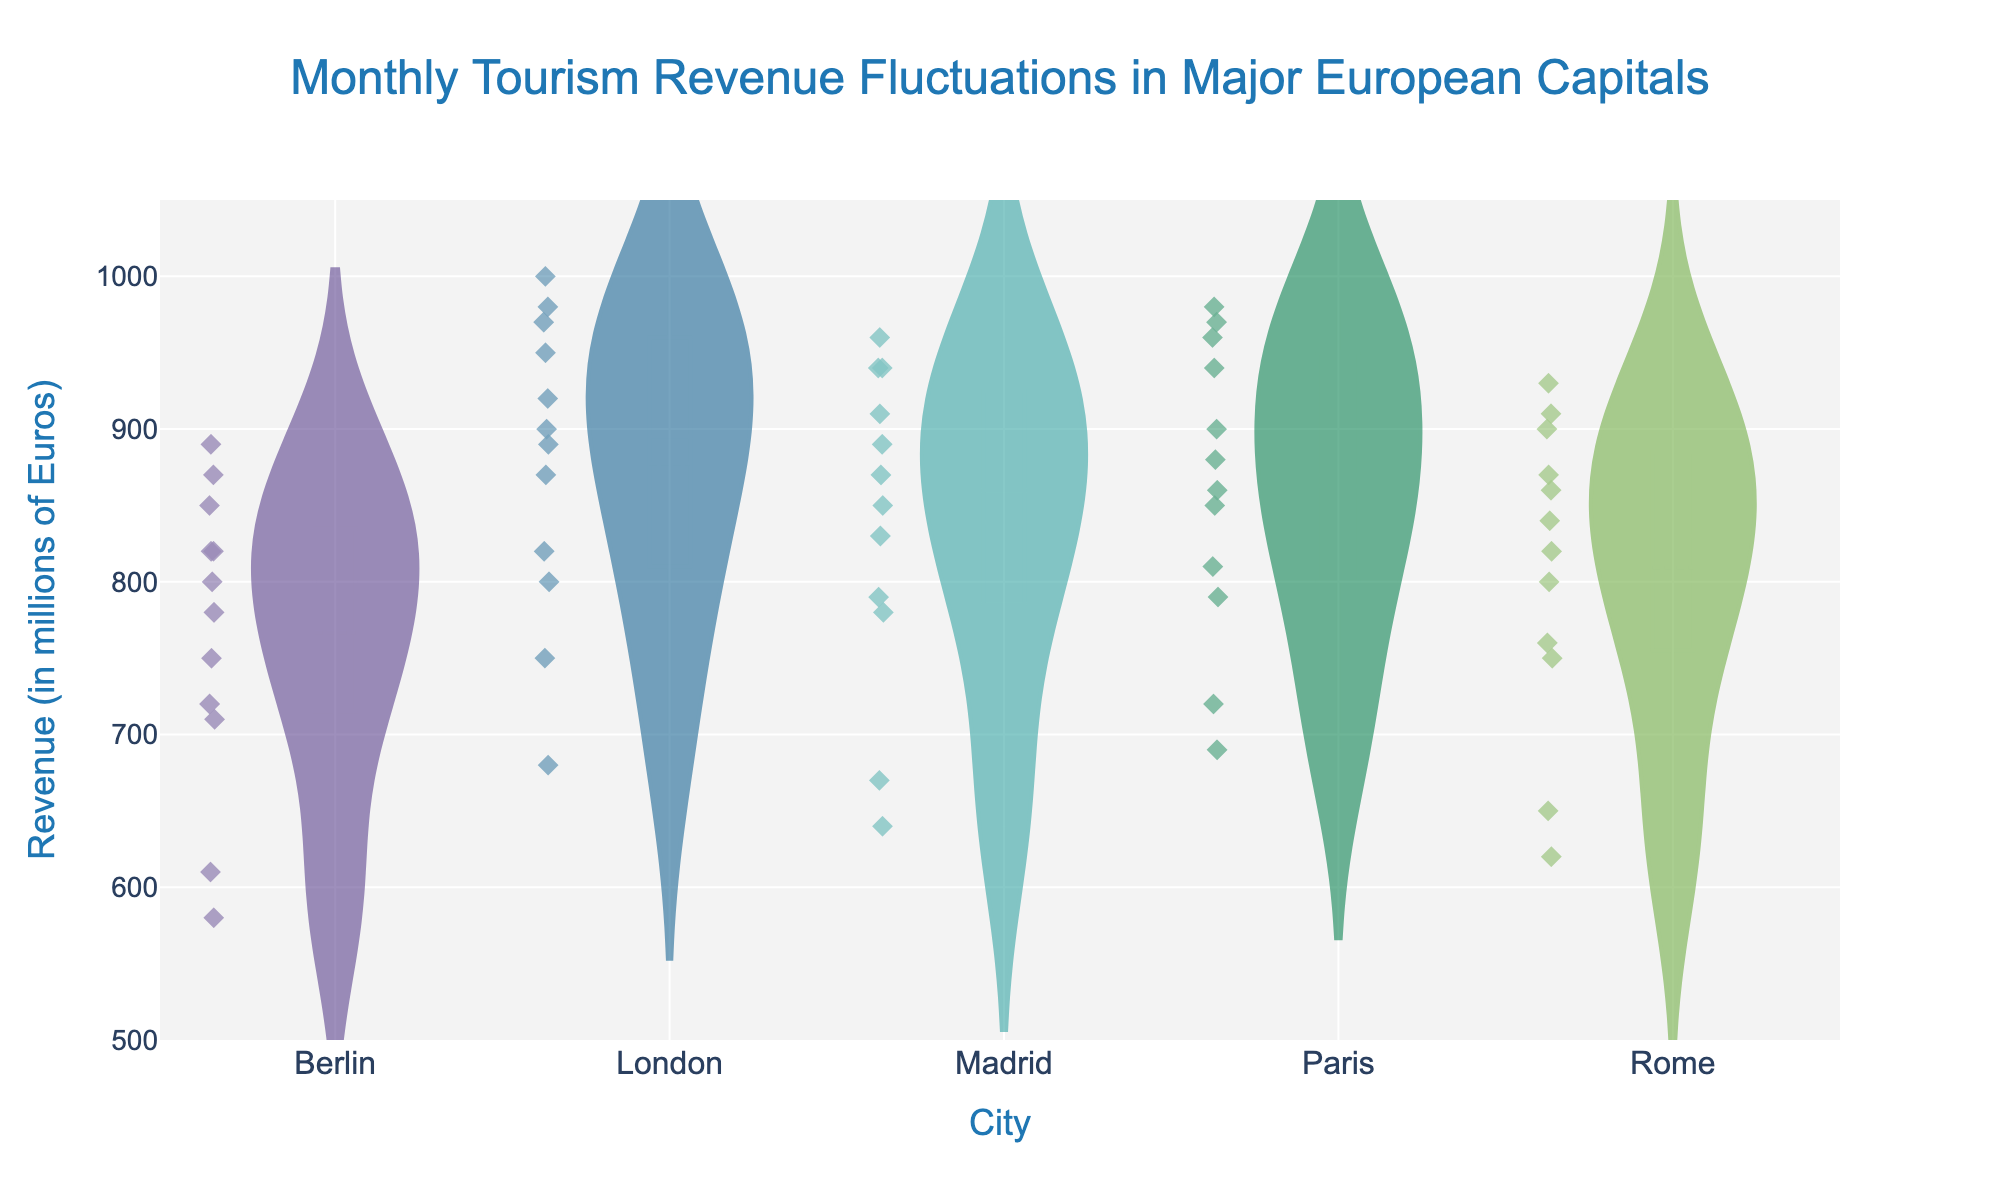Which city shows the highest peak in monthly tourism revenue? By checking the figure, London has the highest peak at 1000 million Euros in July.
Answer: London What is the range of revenue for Berlin in the violin plot? The range can be determined by finding the difference between the highest and lowest points in Berlin's violin plot. The highest is about 890 million Euros, and the lowest is 580 million Euros. The range is 890 - 580 = 310 million Euros.
Answer: 310 million Euros Which city has the most stable (least fluctuating) tourism revenue based on the violin plot? The stability can be assessed by the width and spread of the violin plot. Paris appears to have the least spread and is the most stable compared to the other cities.
Answer: Paris Compare the medians of Paris and Rome. Which city has a higher median revenue? The median value is indicated by the horizontal line inside the box plot. Paris' median is higher than Rome's.
Answer: Paris In which month does London see the highest tourism revenue based on the box plot overlay? The specific month responsible for the highest revenue can be viewed directly on the figure. London's highest revenue occurs in July.
Answer: July What is the median value of Madrid's tourism revenue across the months? The median of Madrid's violin plot, marked by the line inside its box, is around 870 million Euros.
Answer: 870 million Euros Which city shows greater revenue variability, London or Berlin? Variability can be assessed by the spread and width of the violin plot. Berlin shows a wider and more variable revenue distribution compared to London.
Answer: Berlin During which month does Rome see its lowest tourism revenue? By examining the monthly distribution in the violin for Rome, the lowest point is in February.
Answer: February What is the interquartile range (IQR) of revenue for Madrid? The IQR is the difference between the upper and lower quartile boundaries of the box plot. For Madrid, these values are about 940 million Euros (75th percentile) and 780 million Euros (25th percentile). The IQR is 940 - 780 = 160 million Euros.
Answer: 160 million Euros How does London's revenue in January compare to its revenue in December? Comparing the two months' positions in London's violin plot, January's revenue is 750 million, while December's is higher at 900 million Euros.
Answer: December's revenue is higher 